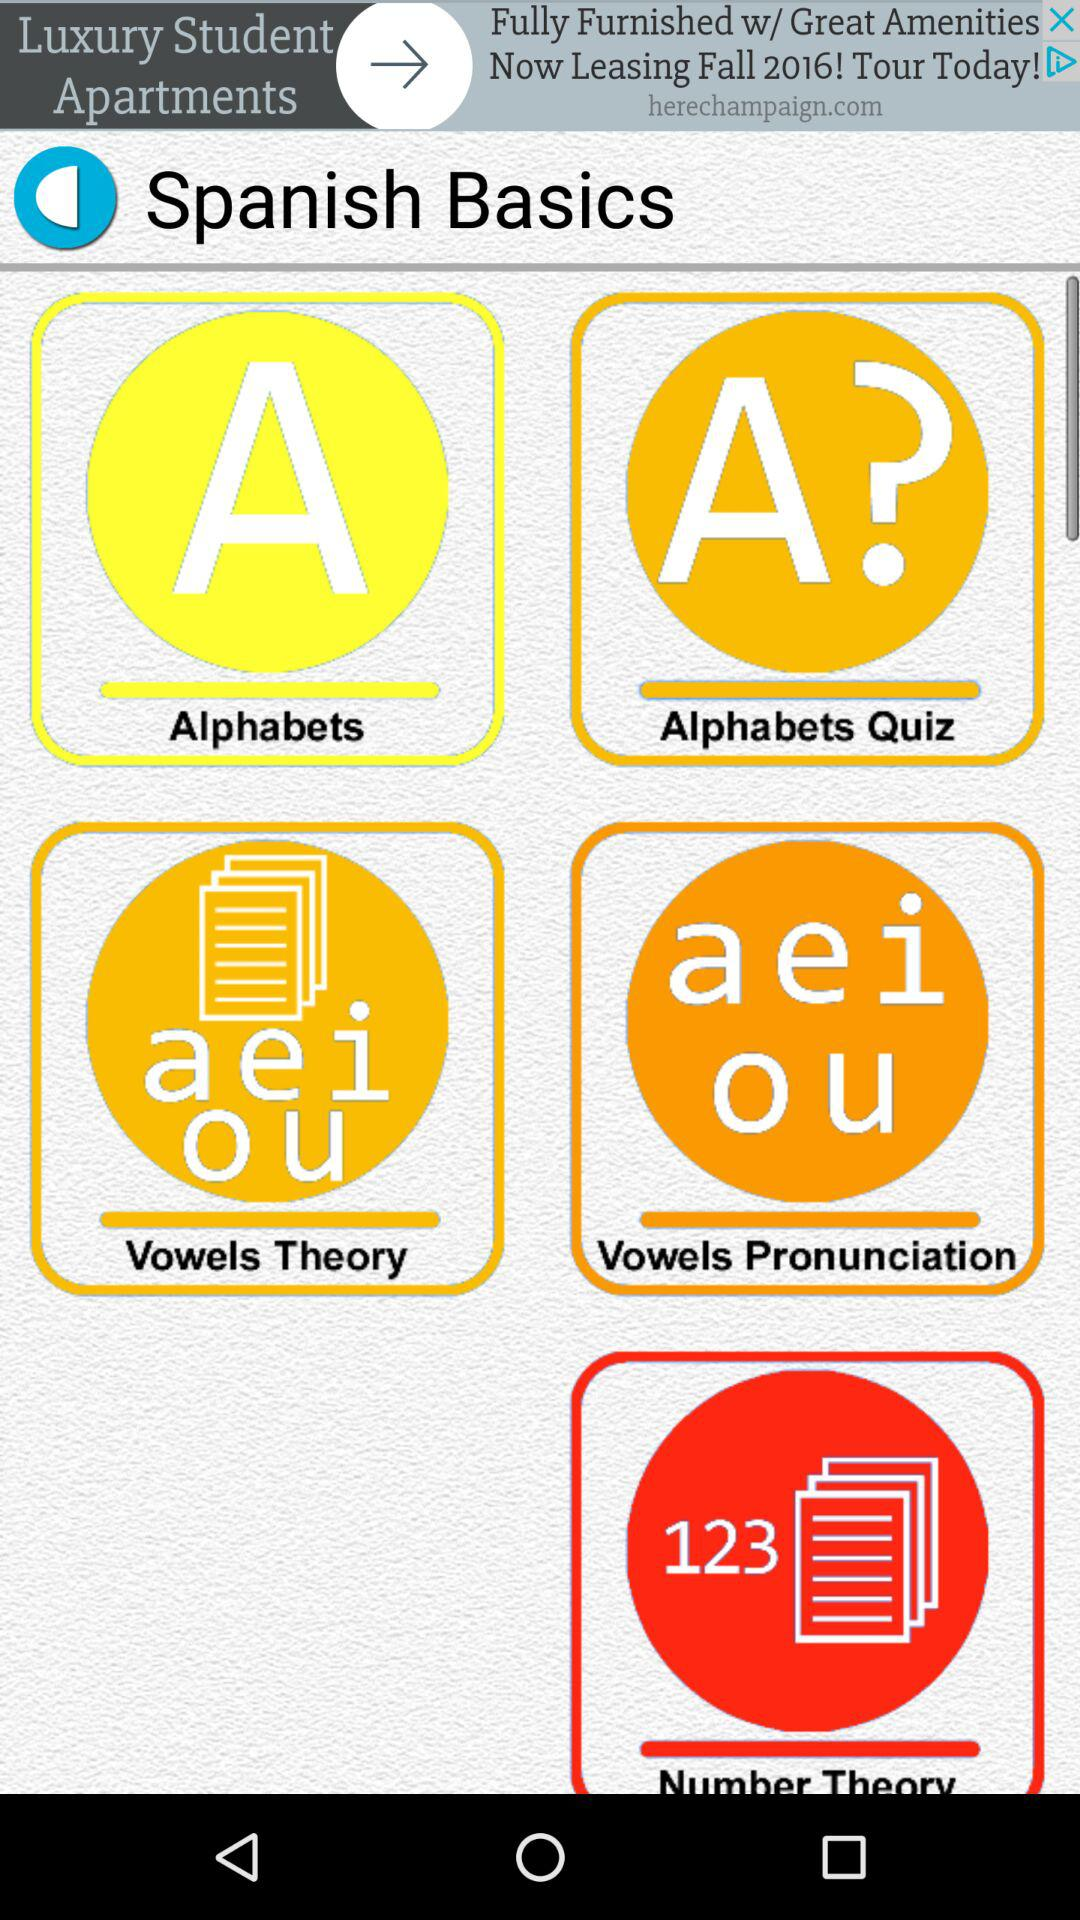What is the application name? The application name is "Spanish Basics". 